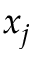Convert formula to latex. <formula><loc_0><loc_0><loc_500><loc_500>x _ { j }</formula> 